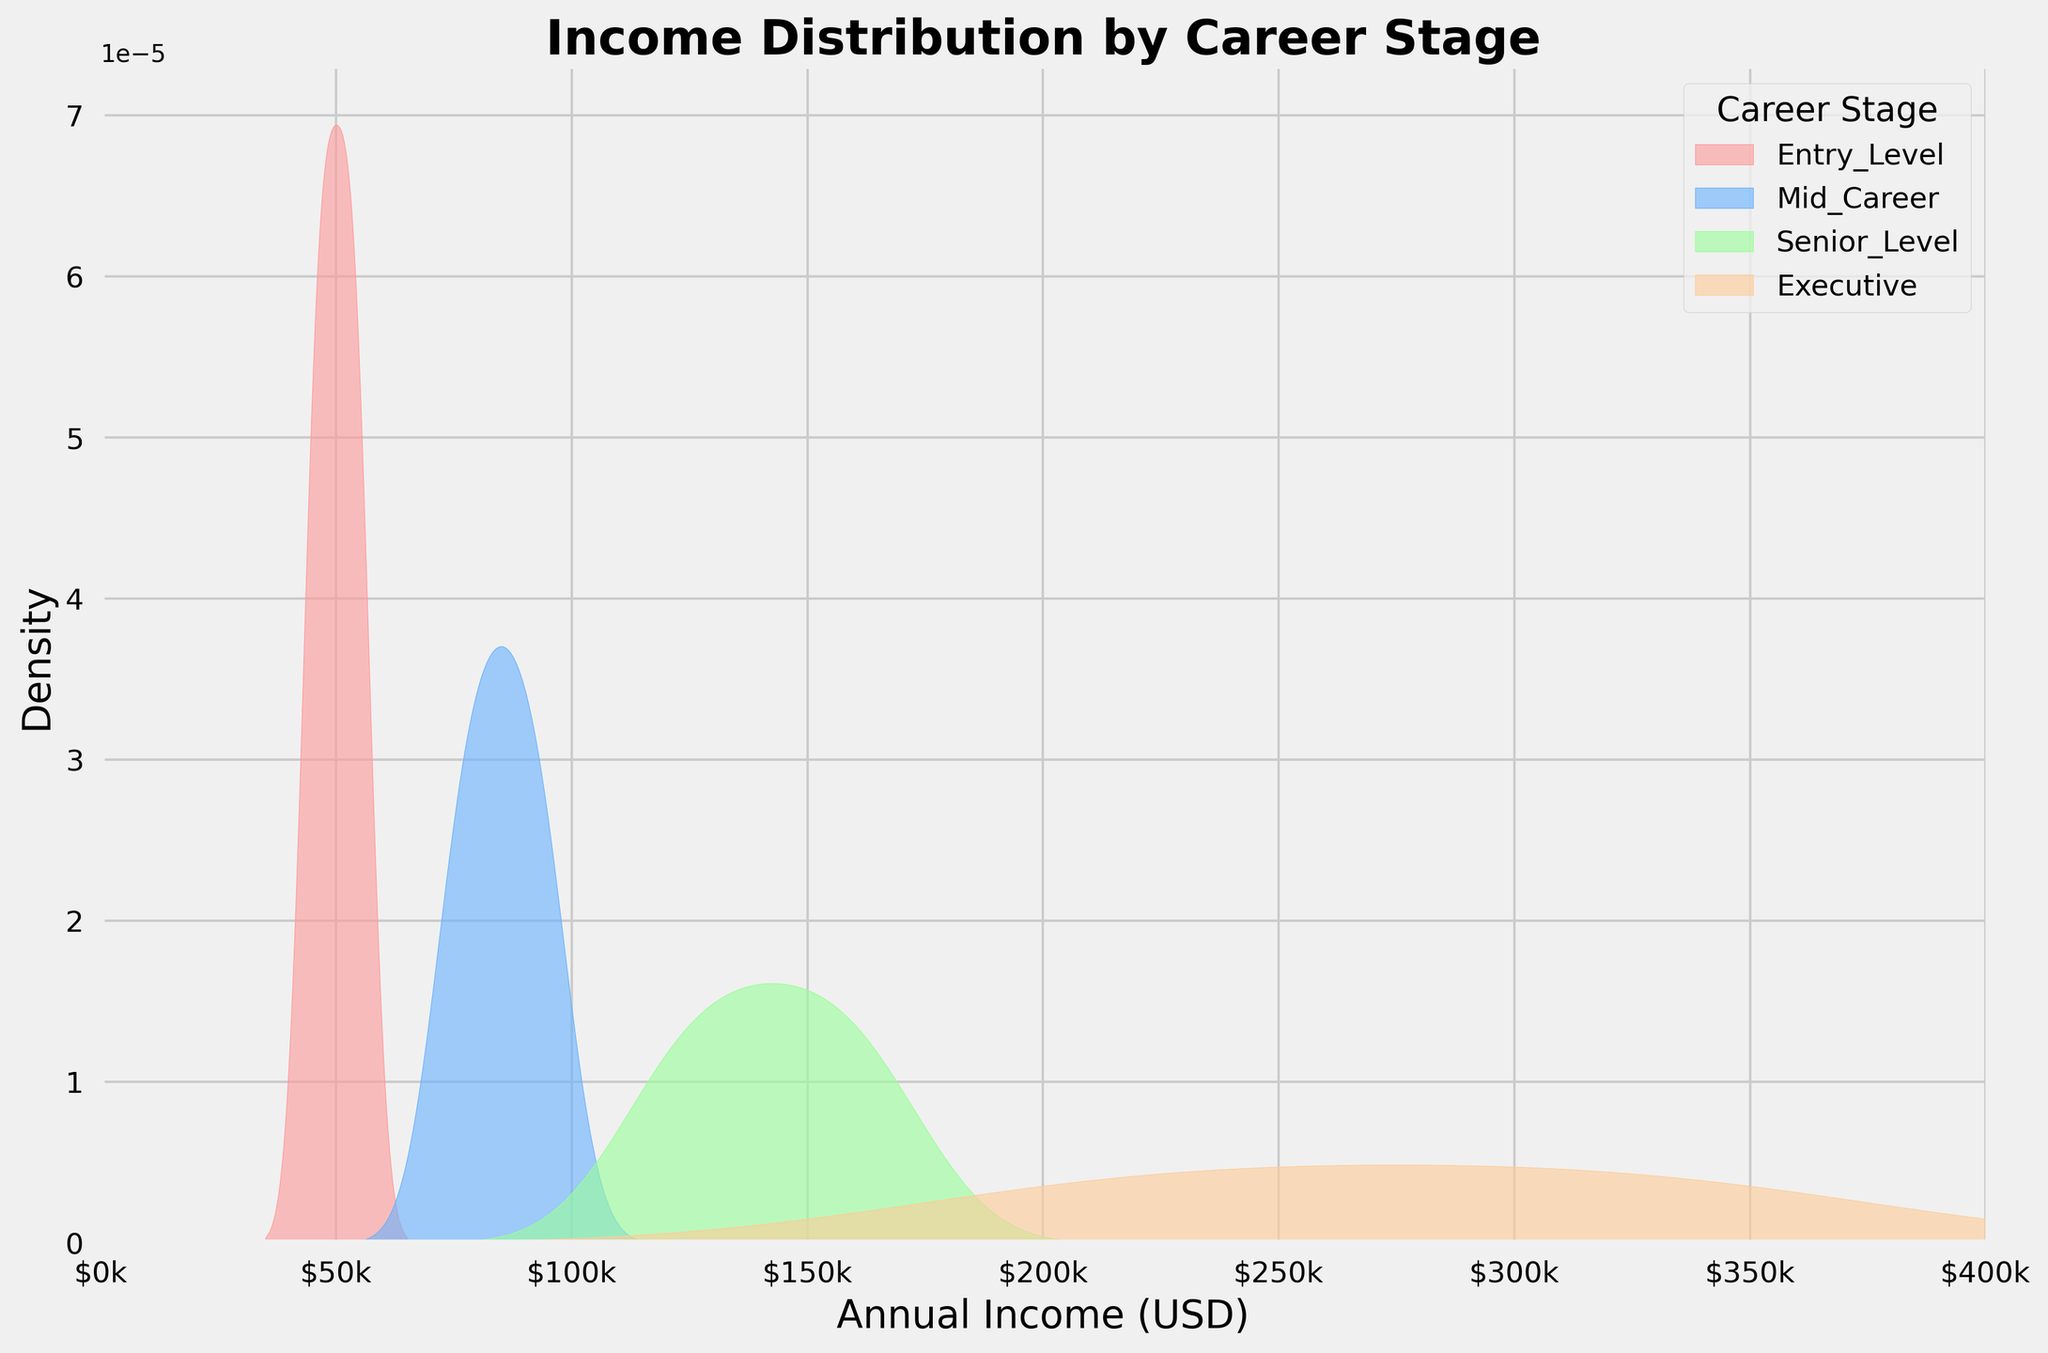what is the title of the plot? The title is displayed at the top center of the plot in a bold font. It gives an overview of the figure.
Answer: Income Distribution by Career Stage what does the x-axis represent? The x-axis is labeled at the bottom of the plot. It represents the Annual Income (USD) distribution across different career stages.
Answer: Annual Income (USD) how many career stages are represented in the plot? By looking at the legend located within the plot area, we can count the number of unique labels or groups.
Answer: Four which career stage has the highest peak density? The career stage with the highest peak on the density plot indicates the highest concentration of that group's annual income. By comparing the peak heights, one can see which is the tallest.
Answer: Entry-Level what's the approximate range of annual income for the executives? By observing the density plot for the Executive group, its distribution falls between certain x-axis values.
Answer: 200,000 to 350,000 USD which career stage has the broadest income distribution? The career stage with the widest spread on the x-axis, shown by the range of its density curve, represents the broadest income distribution.
Answer: Executive how do the income distributions of mid-career and senior-level professionals compare? The Mid-Career density curve is generally lower and concentrated towards the left compared to the Senior-Level, indicating higher and more spread out income for Senior-Level professionals.
Answer: Senior-Level has higher and more spread income is there any career stage with income distribution showing multiple peaks? Only the density plot of the career stage with more than one prominent peak indicates multiple income concentrations. This requires careful observation of each curve.
Answer: No what can you infer about the density distribution for entry-level professionals? Entry-Level density plot has a sharp peak, indicating most professionals have similar incomes, concentrated around a specific range. The curve does not spread much.
Answer: Most professionals earn around the same income level do mid-career professionals have a higher density peak than senior-level ones? By comparing the height of the Mid-Career and Senior-Level density peaks, it's clear which career stage has a higher peak.
Answer: No 